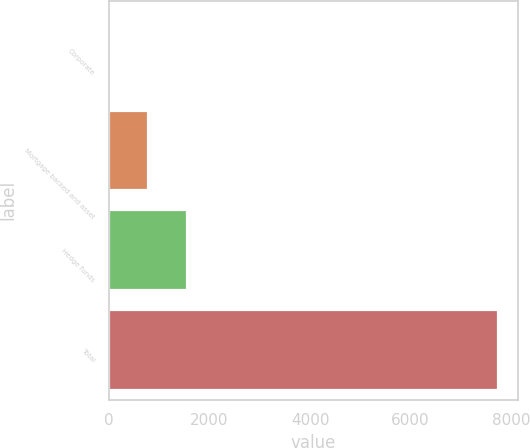<chart> <loc_0><loc_0><loc_500><loc_500><bar_chart><fcel>Corporate<fcel>Mortgage backed and asset<fcel>Hedge funds<fcel>Total<nl><fcel>3<fcel>777.2<fcel>1551.4<fcel>7745<nl></chart> 